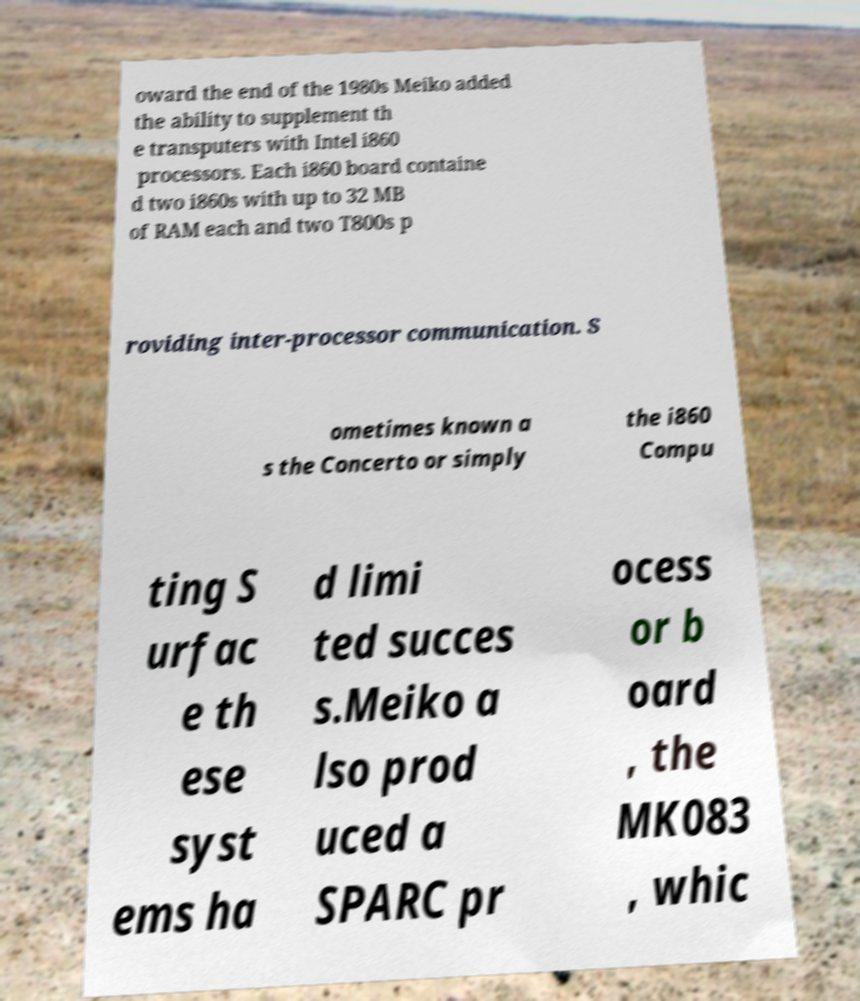Could you extract and type out the text from this image? oward the end of the 1980s Meiko added the ability to supplement th e transputers with Intel i860 processors. Each i860 board containe d two i860s with up to 32 MB of RAM each and two T800s p roviding inter-processor communication. S ometimes known a s the Concerto or simply the i860 Compu ting S urfac e th ese syst ems ha d limi ted succes s.Meiko a lso prod uced a SPARC pr ocess or b oard , the MK083 , whic 